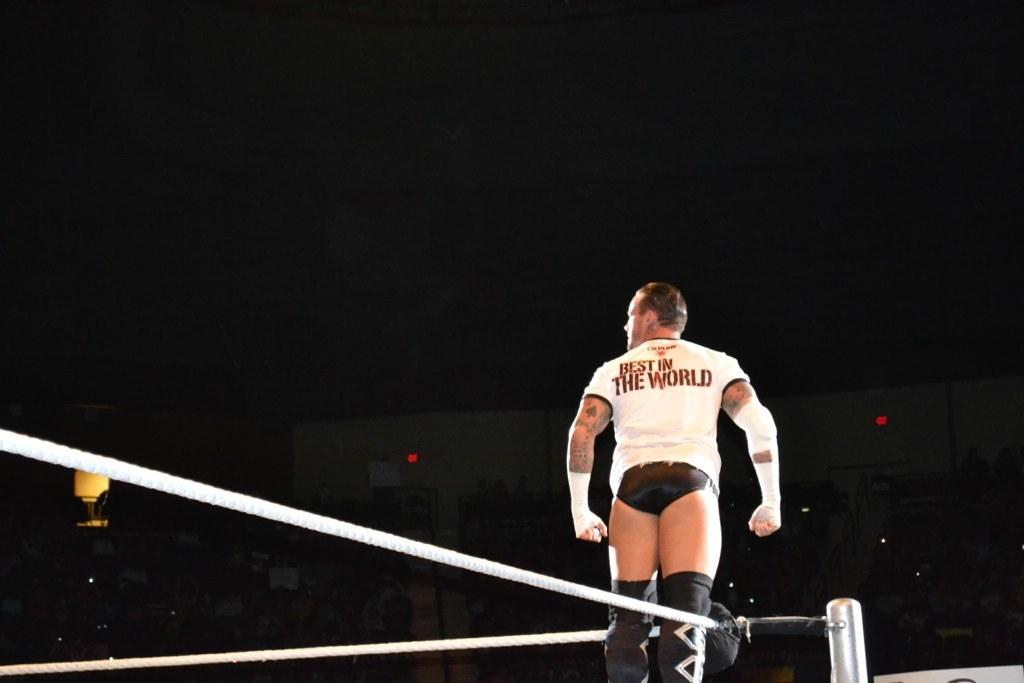What is the main subject of the image? There is a man standing in the image. What objects are present in the image? There is a rope and a pole in the image. What can be seen in the background of the image? There is a building, lights, and a parachute visible in the background of the image. What type of bear can be seen climbing the pole in the image? There is no bear present in the image, and therefore no such activity can be observed. Can you tell me how many tigers are holding the rope in the image? There are no tigers present in the image, and therefore no such activity can be observed. 